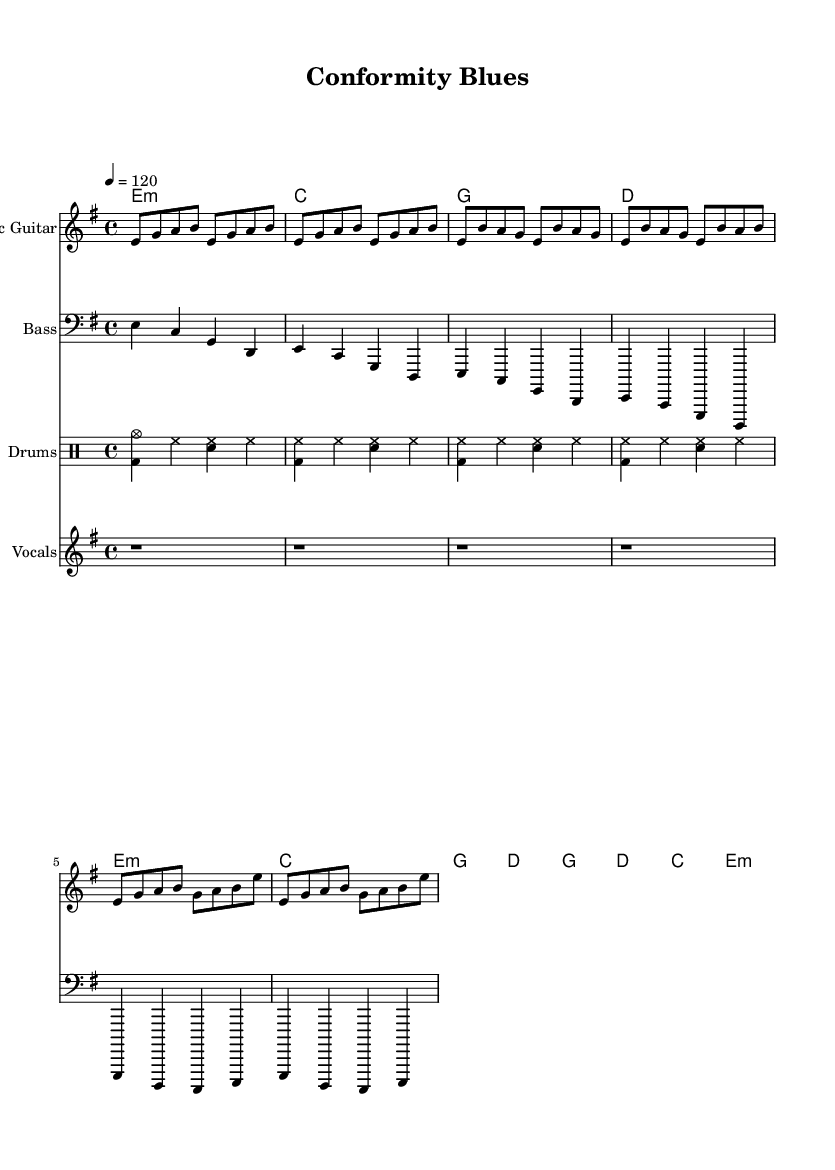What is the key signature of this music? The key signature shows E minor, indicated by one sharp (F#). This is confirmed by the presence of F# notes within the piece.
Answer: E minor What is the time signature of this music? The time signature is indicated as 4/4, which is a common signature in rock music, allowing for a steady rhythm. This is directly visible at the beginning of the score.
Answer: 4/4 What is the tempo of this music? The tempo marking states "4 = 120," meaning each quarter note (1 beat) is played at 120 beats per minute. This indicates a brisk and energetic pace typical of rock songs.
Answer: 120 How many bars are there in the intro section? There are four measures indicated in the intro section of the electric guitar part. This can be counted visually based on the notation provided.
Answer: 4 What chord is played in the chorus? The chorus section features the chords G, D, C, and E minor, as shown in the chord part. This alignment with the typical chord progression reflects the structure of many rock songs.
Answer: G, D, C, E minor Which instrument typically provides a steady backbeat in this piece? The drums provide a steady backbeat throughout the piece, as indicated by the drummode part, often playing consistently in common rock styles.
Answer: Drums What style of lyrics would typically accompany this music? The lyrics would likely be satirical, critiquing societal norms and conformity, as suggested by the title "Conformity Blues" and is a common theme in satirical rock songs.
Answer: Satirical 